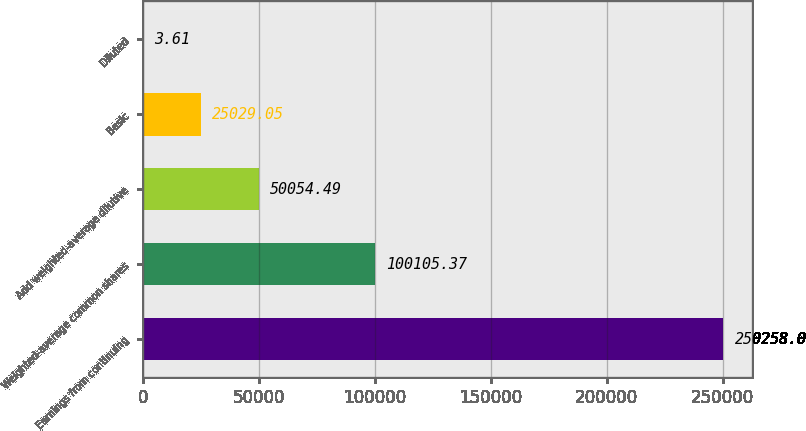Convert chart to OTSL. <chart><loc_0><loc_0><loc_500><loc_500><bar_chart><fcel>Earnings from continuing<fcel>Weighted-average common shares<fcel>Add weighted-average dilutive<fcel>Basic<fcel>Diluted<nl><fcel>250258<fcel>100105<fcel>50054.5<fcel>25029<fcel>3.61<nl></chart> 